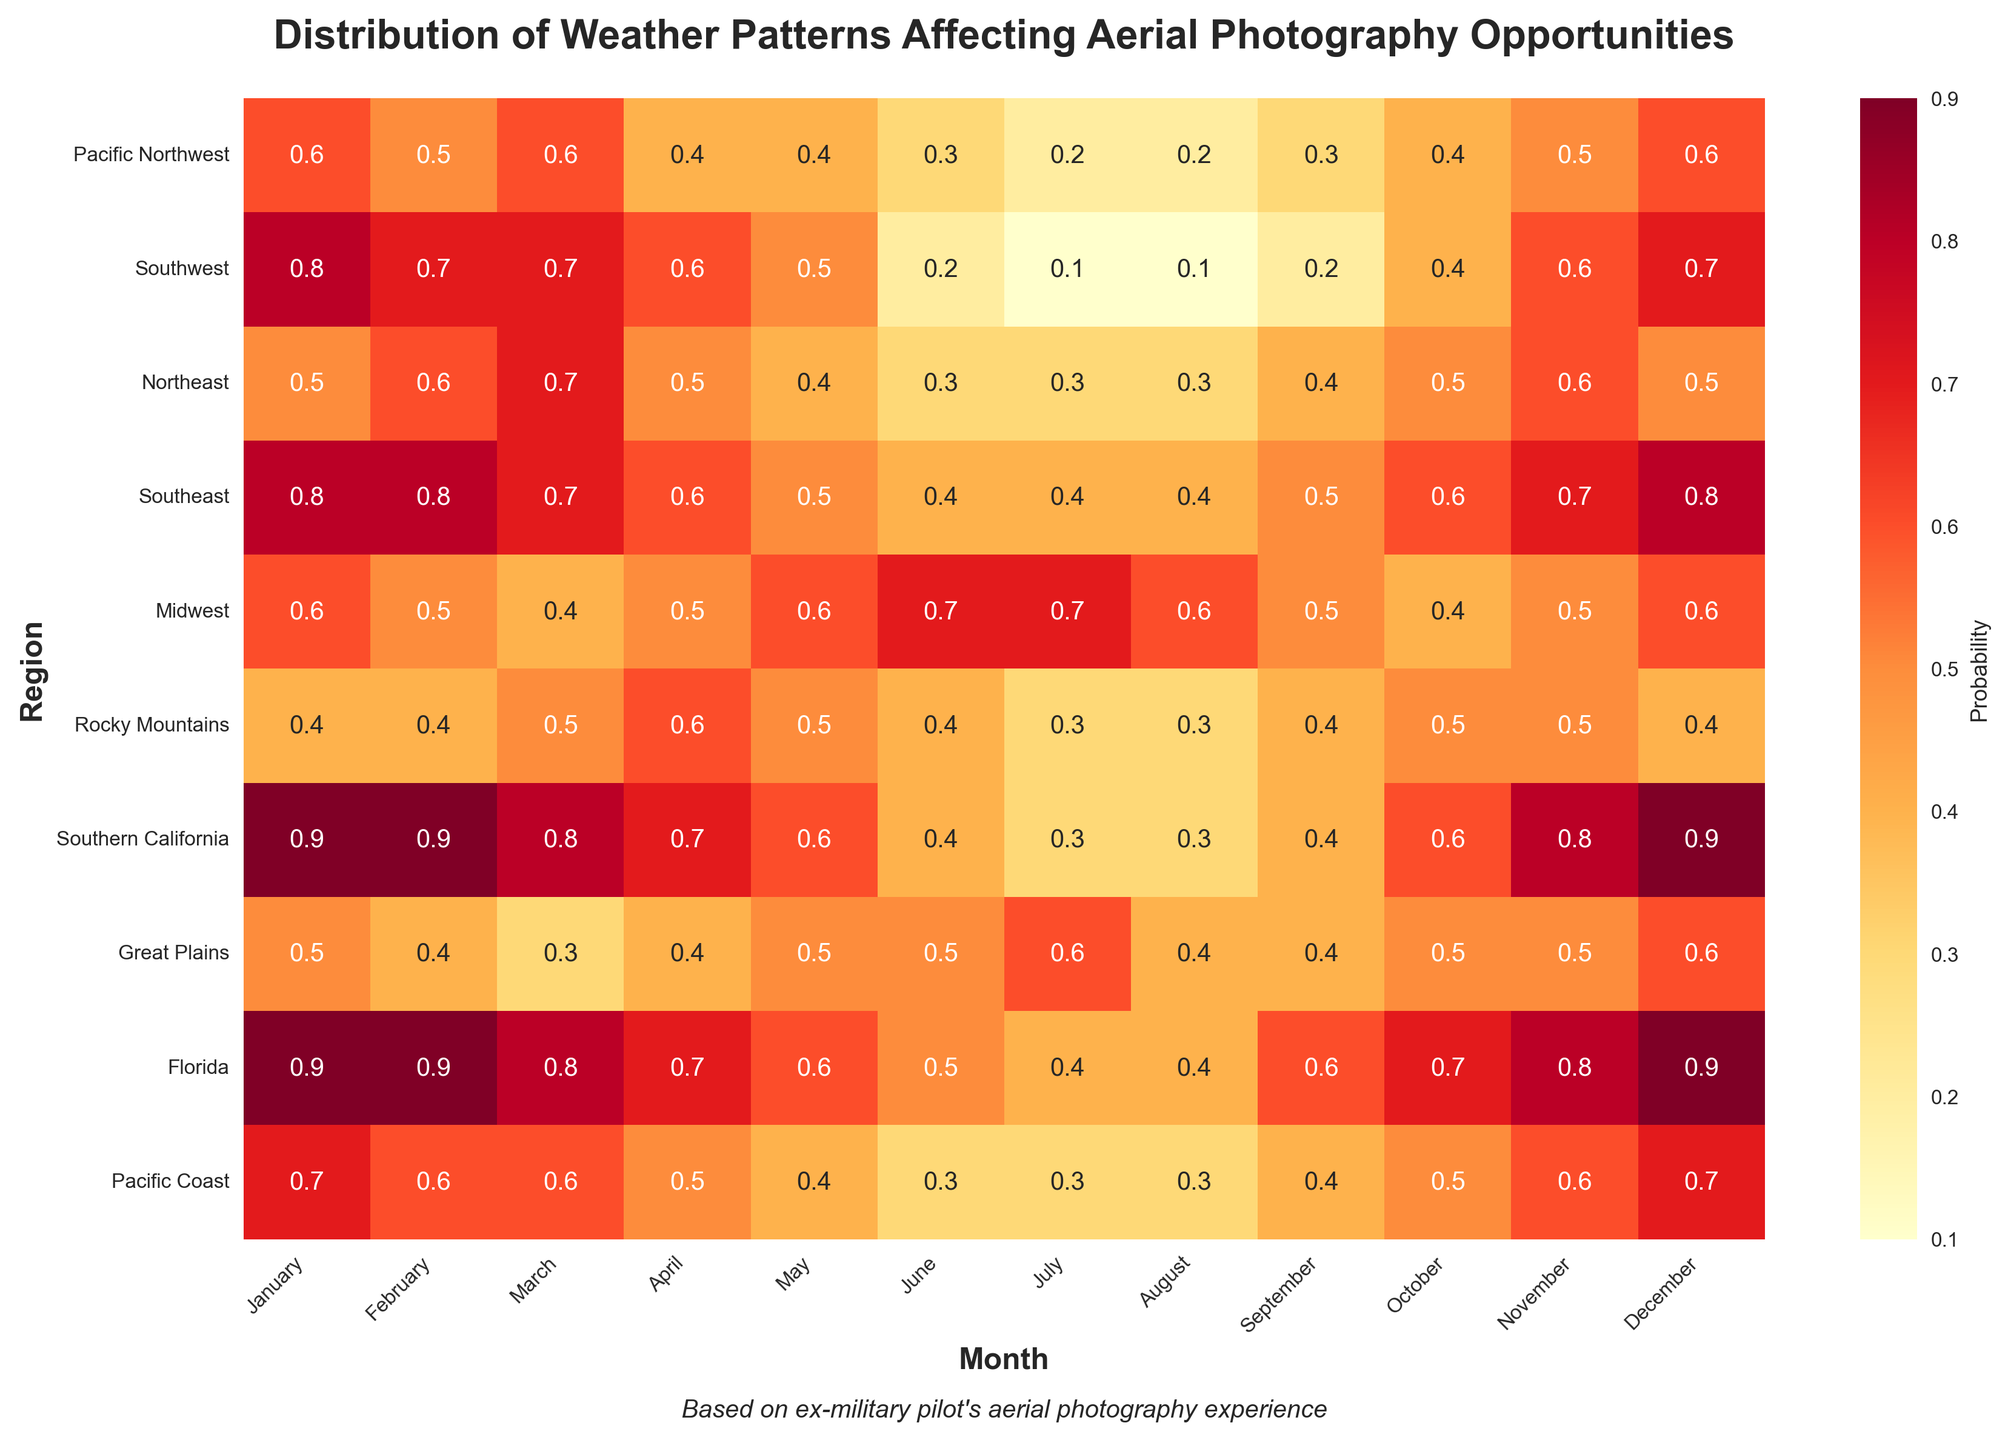What's the title of the heatmap? The title of the heatmap is displayed prominently at the top of the plot.
Answer: Distribution of Weather Patterns Affecting Aerial Photography Opportunities Which region has the highest probability in January? To find the region with the highest probability in January, look at the first column under January and find the maximum value.
Answer: Florida and Southern California What is the average probability of good photography conditions in the Pacific Northwest throughout the year? Add up all the monthly probabilities for the Pacific Northwest, then divide by 12. (0.6 + 0.5 + 0.6 + 0.4 + 0.4 + 0.3 + 0.2 + 0.2 + 0.3 + 0.4 + 0.5 + 0.6) / 12 = 5 / 12
Answer: 0.42 Which month shows the lowest average probability across all regions? Calculate the average probabilities for each month and find the minimum. For example, January: (0.6 + 0.8 + 0.5 + 0.8 + 0.6 + 0.4 + 0.9 + 0.5 + 0.9 + 0.7) / 10 = 0.67. Repeat for all months and compare.
Answer: July How does the probability of good photography conditions in the Rocky Mountains vary between April and August? Compare the probabilities for April and August in the Rocky Mountains row. April has 0.6 and August has 0.3. The probability decreases from April to August.
Answer: Decreases Which region consistently has high probabilities (>= 0.8) during winter months (December to February)? Look for regions with all values >= 0.8 in December, January, and February. Southern California and Florida meet this criterion.
Answer: Southern California and Florida In which months does the Midwest have its highest probability values? Check the row for the Midwest and identify months with the highest values. June and July have 0.7
Answer: June and July Is there any region where the probability stays constant for three consecutive months? Scan the heatmap to find any regions with the same values for any three consecutive months. The Rocky Mountains have a value of 0.4 from December to February.
Answer: Rocky Mountains What's the difference in the probability of good photography conditions between January and July for the Southwest? Check the values for January and July in the Southwest row, then subtract the values. 0.8 (January) - 0.1 (July) = 0.7
Answer: 0.7 